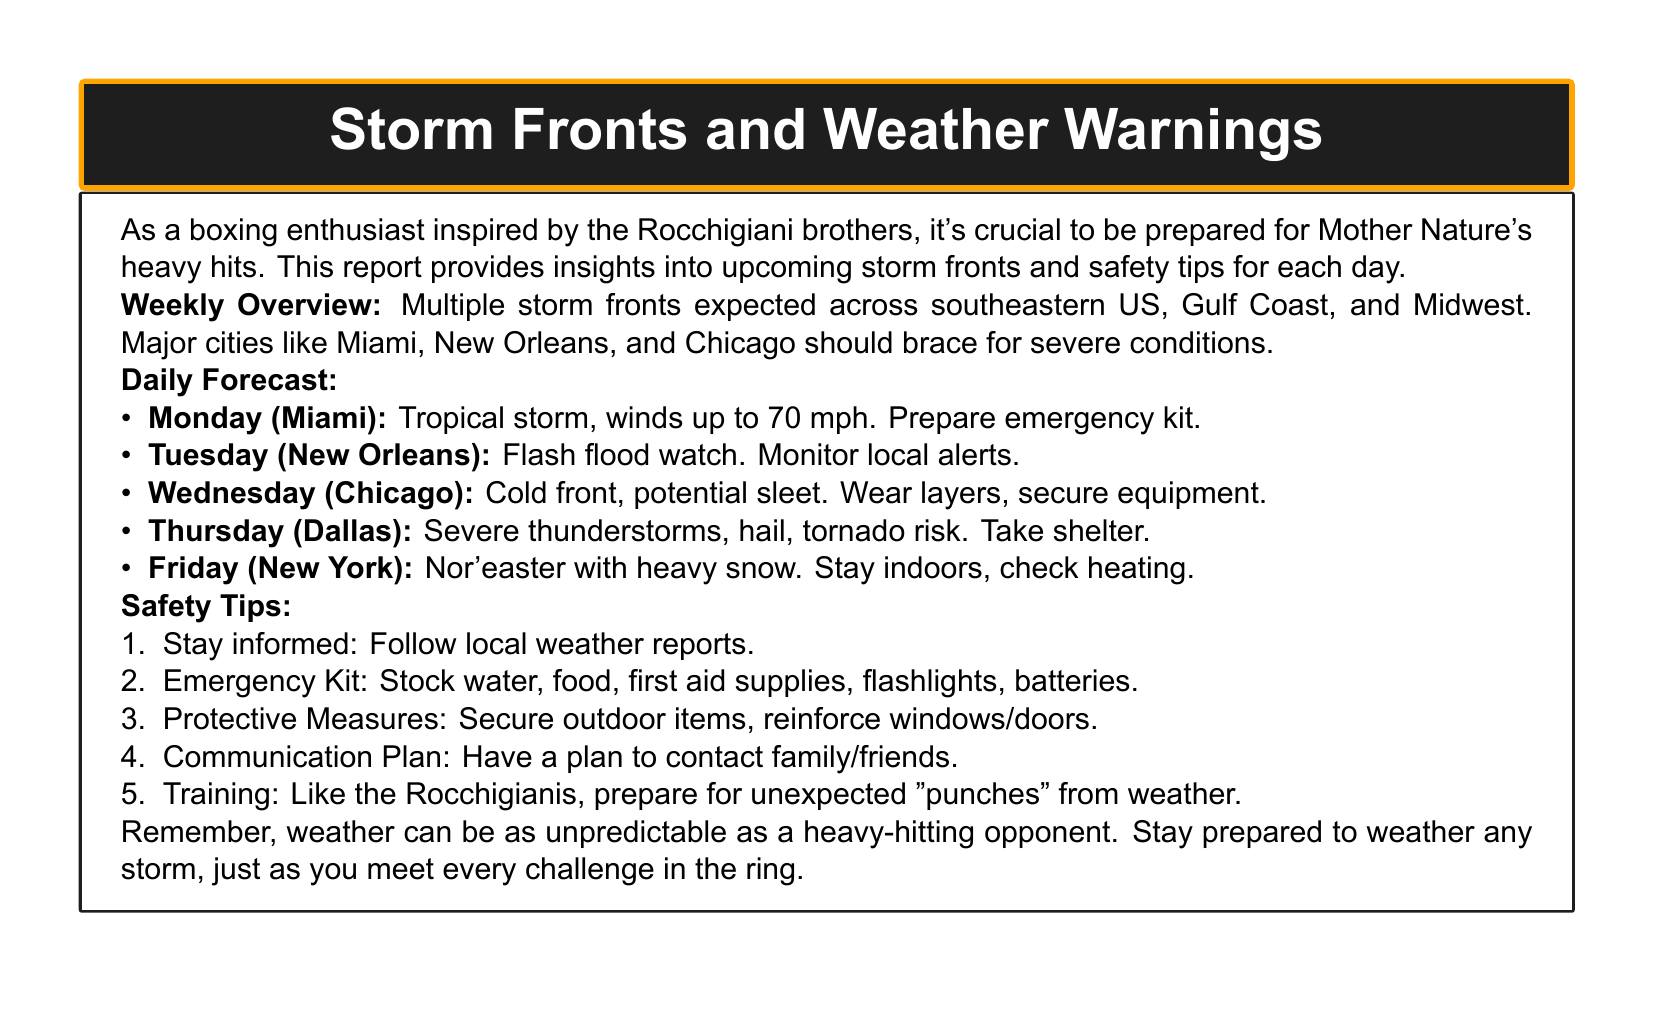What storm is expected on Monday? The document states that a tropical storm is expected on Monday in Miami with winds up to 70 mph.
Answer: Tropical storm What should residents of New Orleans monitor on Tuesday? The document indicates that residents should monitor local alerts due to a flash flood watch on Tuesday.
Answer: Local alerts What is the primary weather condition in Chicago on Wednesday? The report mentions a cold front with potential sleet forecasted for Chicago on Wednesday.
Answer: Sleet What safety measure should be taken during Thursday's severe thunderstorms? The document advises taking shelter due to severe thunderstorms, hail, and tornado risk on Thursday.
Answer: Take shelter What items are recommended for the emergency kit? The document lists water, food, first aid supplies, flashlights, and batteries as essential items for the emergency kit.
Answer: Water, food, first aid supplies, flashlights, batteries Which city is expected to experience heavy snow on Friday? The report specifies that New York is expected to face a nor'easter with heavy snow on Friday.
Answer: New York What is the expected wind speed for the tropical storm on Monday? The document specifies that the tropical storm is expected to produce winds up to 70 mph on Monday.
Answer: 70 mph What is the overall weather condition for the week in the southeastern US? The document provides an overview stating multiple storm fronts are expected across southeastern US.
Answer: Multiple storm fronts What kind of preparation is likened to the Rocchigianis in the safety tips? The document references the need for training and preparation for unexpected weather events, akin to preparing for punches in boxing.
Answer: Preparing for unexpected "punches" 